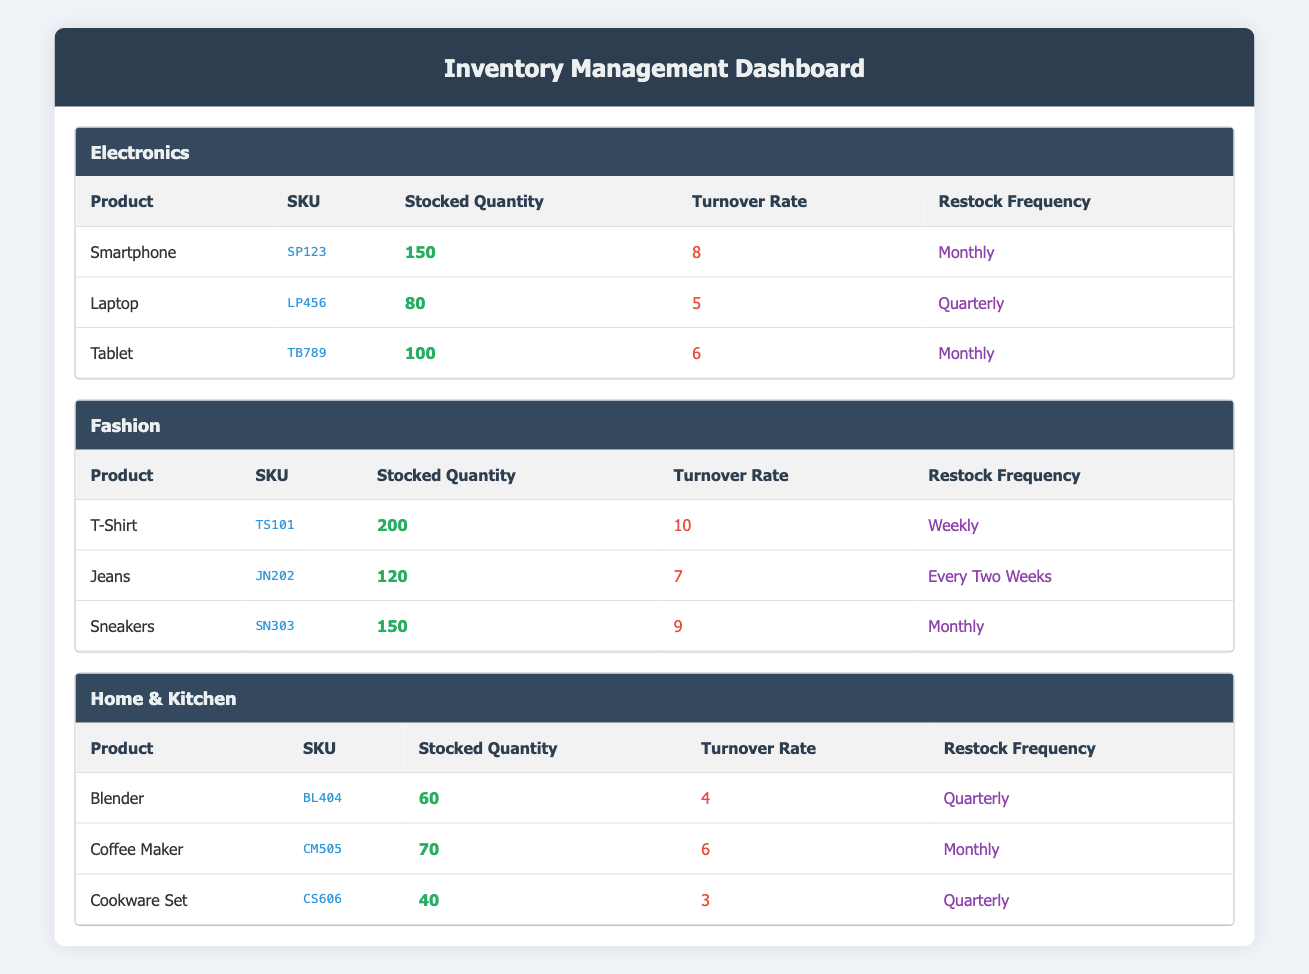What is the turnover rate for the Smartphone? Looking at the Electronics category, the Smartphone has a turnover rate listed in the table, which shows it is 8.
Answer: 8 Which product has the highest stocked quantity in the Fashion category? In the Fashion category, I check the stocked quantities of T-Shirt (200), Jeans (120), and Sneakers (150). The T-Shirt has the highest quantity at 200.
Answer: T-Shirt Is the Coffee Maker restocked weekly? The Coffee Maker in the Home & Kitchen category has a restock frequency listed as "Monthly," so it is not restocked weekly.
Answer: No What is the average turnover rate for the products in the Home & Kitchen category? I gather turnover rates for the Home & Kitchen products: Blender (4), Coffee Maker (6), and Cookware Set (3). The average is calculated as (4 + 6 + 3) / 3 = 4.33.
Answer: 4.33 Which category has the lowest average turnover rate? I calculate the average turnover rates for each category: Electronics (average of 6.33), Fashion (average of 8.67), and Home & Kitchen (average of 4.33). The Home & Kitchen category has the lowest average turnover rate.
Answer: Home & Kitchen Do all products in the Electronics category have a turnover rate greater than 4? By checking, I see the Smartphone (8), Laptop (5), and Tablet (6) all have turnover rates greater than 4, confirming the statement is true.
Answer: Yes What is the difference in stocked quantities between the T-Shirt and the Cookware Set? The stocked quantity of the T-Shirt is 200, and for the Cookware Set, it's 40. The difference is calculated as 200 - 40 = 160.
Answer: 160 Which product has the lowest turnover rate and what is its SKU? The products with their turnover rates show that the Cookware Set has the lowest turnover rate of 3 and its SKU is CS606.
Answer: Cookware Set, CS606 How often is the Laptop restocked? Checking the Electronics category, the Laptop's restock frequency is listed as "Quarterly."
Answer: Quarterly 